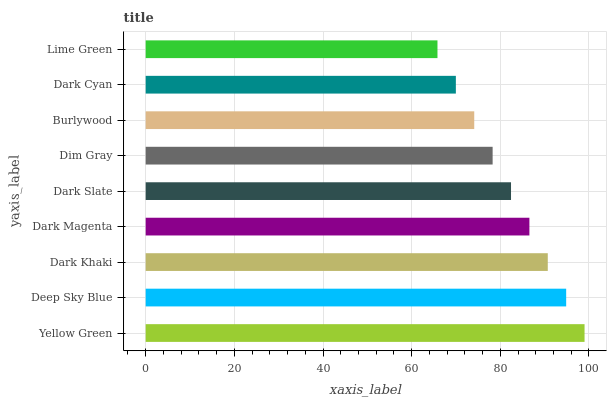Is Lime Green the minimum?
Answer yes or no. Yes. Is Yellow Green the maximum?
Answer yes or no. Yes. Is Deep Sky Blue the minimum?
Answer yes or no. No. Is Deep Sky Blue the maximum?
Answer yes or no. No. Is Yellow Green greater than Deep Sky Blue?
Answer yes or no. Yes. Is Deep Sky Blue less than Yellow Green?
Answer yes or no. Yes. Is Deep Sky Blue greater than Yellow Green?
Answer yes or no. No. Is Yellow Green less than Deep Sky Blue?
Answer yes or no. No. Is Dark Slate the high median?
Answer yes or no. Yes. Is Dark Slate the low median?
Answer yes or no. Yes. Is Dark Khaki the high median?
Answer yes or no. No. Is Lime Green the low median?
Answer yes or no. No. 